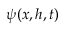<formula> <loc_0><loc_0><loc_500><loc_500>\psi ( x , h , t )</formula> 